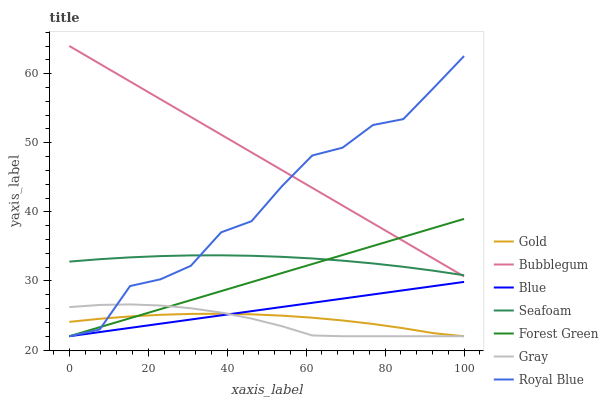Does Gray have the minimum area under the curve?
Answer yes or no. Yes. Does Bubblegum have the maximum area under the curve?
Answer yes or no. Yes. Does Gold have the minimum area under the curve?
Answer yes or no. No. Does Gold have the maximum area under the curve?
Answer yes or no. No. Is Blue the smoothest?
Answer yes or no. Yes. Is Royal Blue the roughest?
Answer yes or no. Yes. Is Gray the smoothest?
Answer yes or no. No. Is Gray the roughest?
Answer yes or no. No. Does Blue have the lowest value?
Answer yes or no. Yes. Does Seafoam have the lowest value?
Answer yes or no. No. Does Bubblegum have the highest value?
Answer yes or no. Yes. Does Gray have the highest value?
Answer yes or no. No. Is Gray less than Seafoam?
Answer yes or no. Yes. Is Bubblegum greater than Blue?
Answer yes or no. Yes. Does Blue intersect Gold?
Answer yes or no. Yes. Is Blue less than Gold?
Answer yes or no. No. Is Blue greater than Gold?
Answer yes or no. No. Does Gray intersect Seafoam?
Answer yes or no. No. 